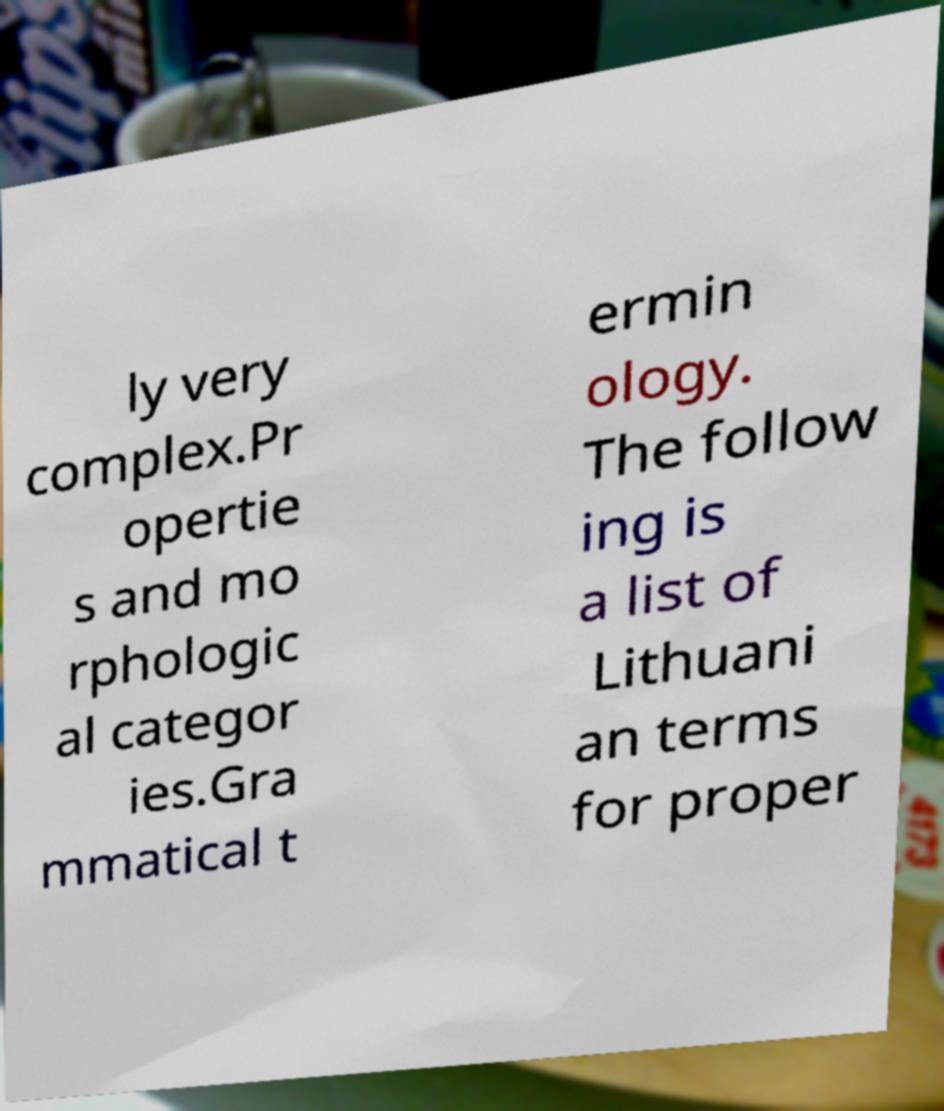Please read and relay the text visible in this image. What does it say? ly very complex.Pr opertie s and mo rphologic al categor ies.Gra mmatical t ermin ology. The follow ing is a list of Lithuani an terms for proper 